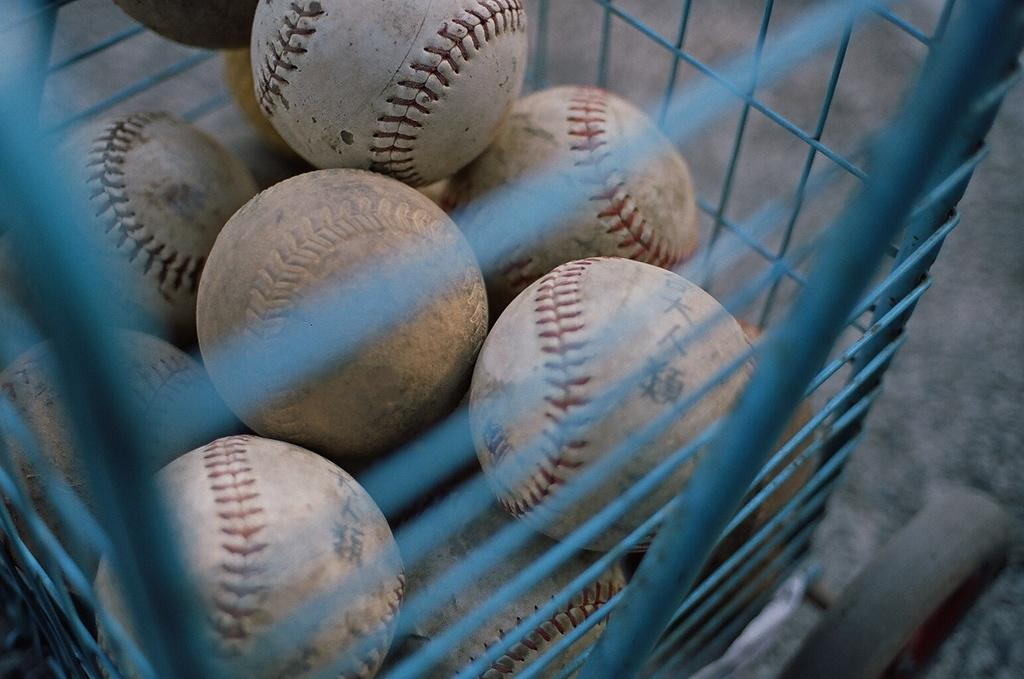What objects are present in the image? There are balls in the image. Where are the balls located? The balls are in a grill trolley. What type of hat is being used to cook the stew in the image? There is no hat or stew present in the image; it features balls in a grill trolley. What color is the sweater worn by the person holding the balls in the image? There is no person or sweater present in the image; it only features balls in a grill trolley. 